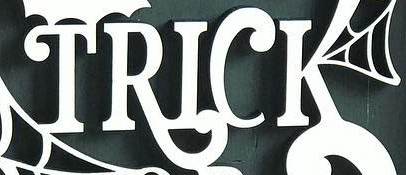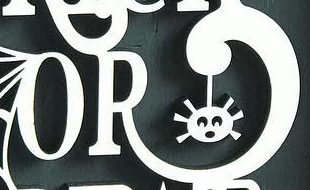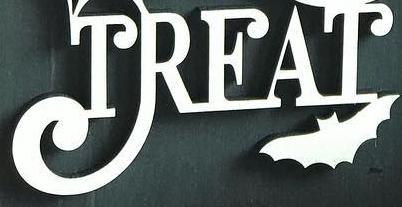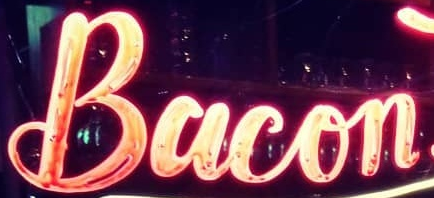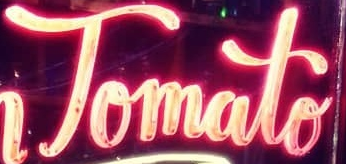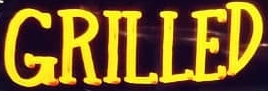Read the text from these images in sequence, separated by a semicolon. TRICK; OR; TREAT; Bacon; Tomato; GRILLED 